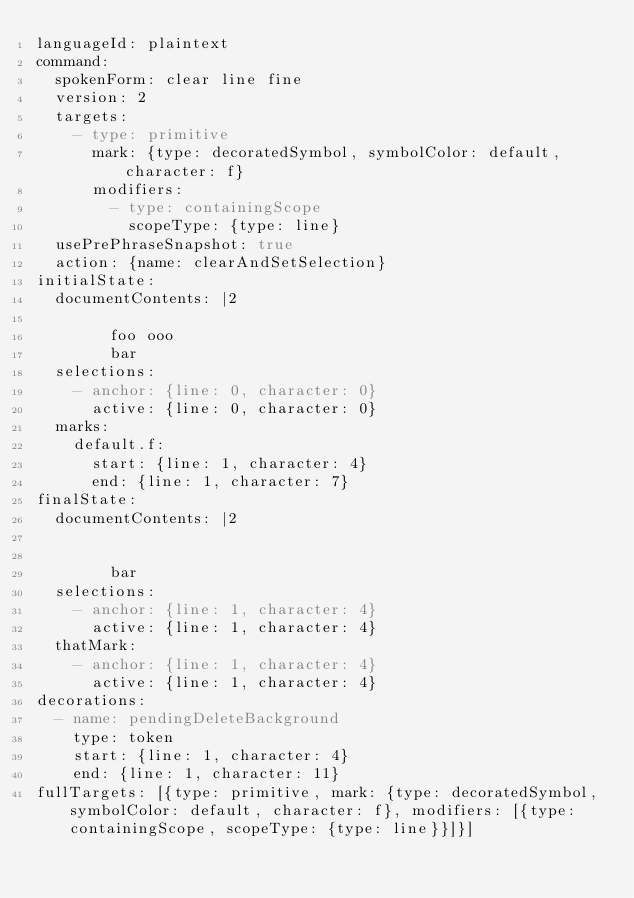<code> <loc_0><loc_0><loc_500><loc_500><_YAML_>languageId: plaintext
command:
  spokenForm: clear line fine
  version: 2
  targets:
    - type: primitive
      mark: {type: decoratedSymbol, symbolColor: default, character: f}
      modifiers:
        - type: containingScope
          scopeType: {type: line}
  usePrePhraseSnapshot: true
  action: {name: clearAndSetSelection}
initialState:
  documentContents: |2

        foo ooo    
        bar    
  selections:
    - anchor: {line: 0, character: 0}
      active: {line: 0, character: 0}
  marks:
    default.f:
      start: {line: 1, character: 4}
      end: {line: 1, character: 7}
finalState:
  documentContents: |2

            
        bar    
  selections:
    - anchor: {line: 1, character: 4}
      active: {line: 1, character: 4}
  thatMark:
    - anchor: {line: 1, character: 4}
      active: {line: 1, character: 4}
decorations:
  - name: pendingDeleteBackground
    type: token
    start: {line: 1, character: 4}
    end: {line: 1, character: 11}
fullTargets: [{type: primitive, mark: {type: decoratedSymbol, symbolColor: default, character: f}, modifiers: [{type: containingScope, scopeType: {type: line}}]}]
</code> 